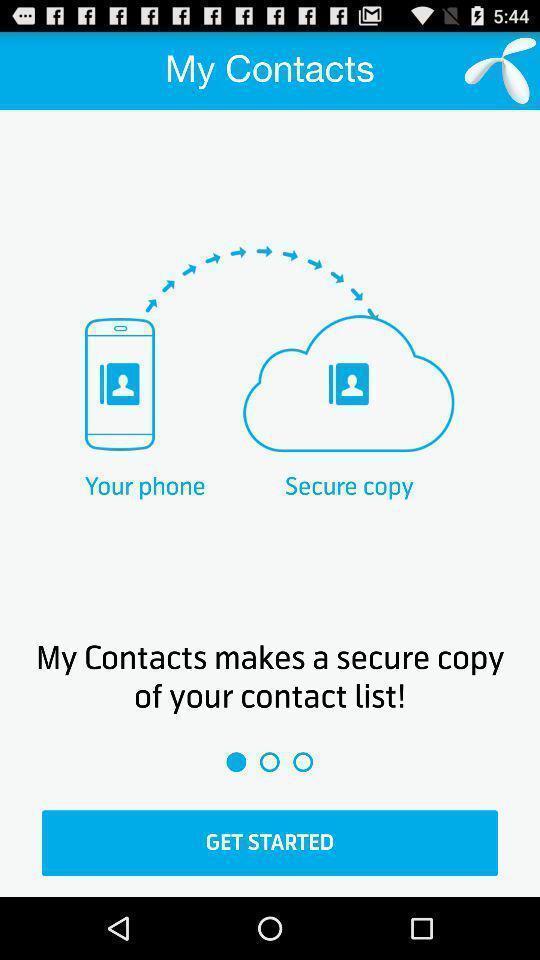Give me a narrative description of this picture. Welcome page with some options in contacts app. 